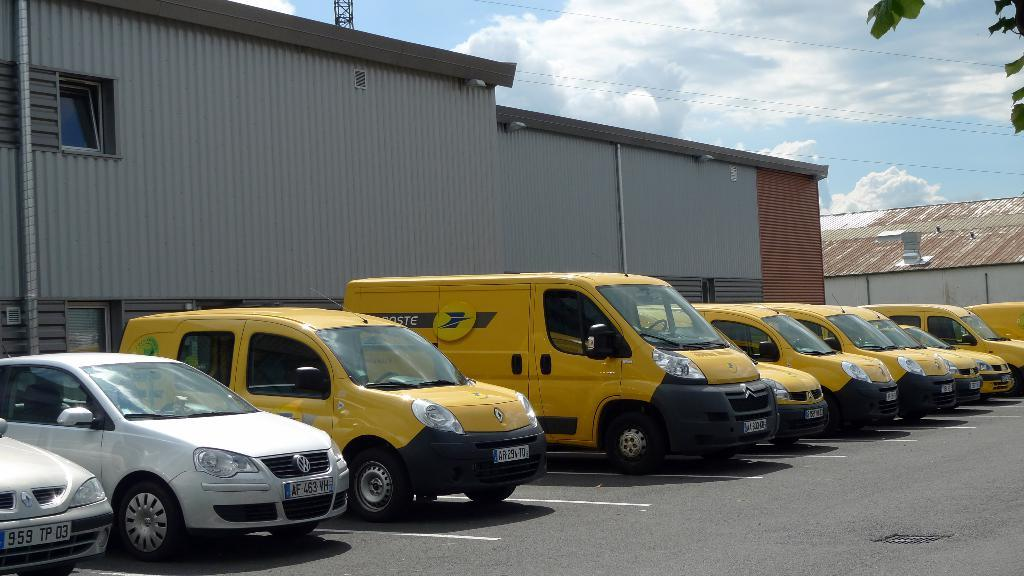Where was the image taken? The image was taken on a road. What can be seen on the road in the image? There are vehicles parked on the road. What is visible behind the parked vehicles? There are buildings behind the parked vehicles. What is visible at the top of the image? The sky is visible at the top of the image. What type of vegetation can be seen in the top right corner of the image? Leaves are present in the top right corner of the image. What type of toy can be seen in the image? There is no toy present in the image. What agreement was reached between the vehicles in the image? There is no agreement between the vehicles in the image, as they are parked and not interacting with each other. 